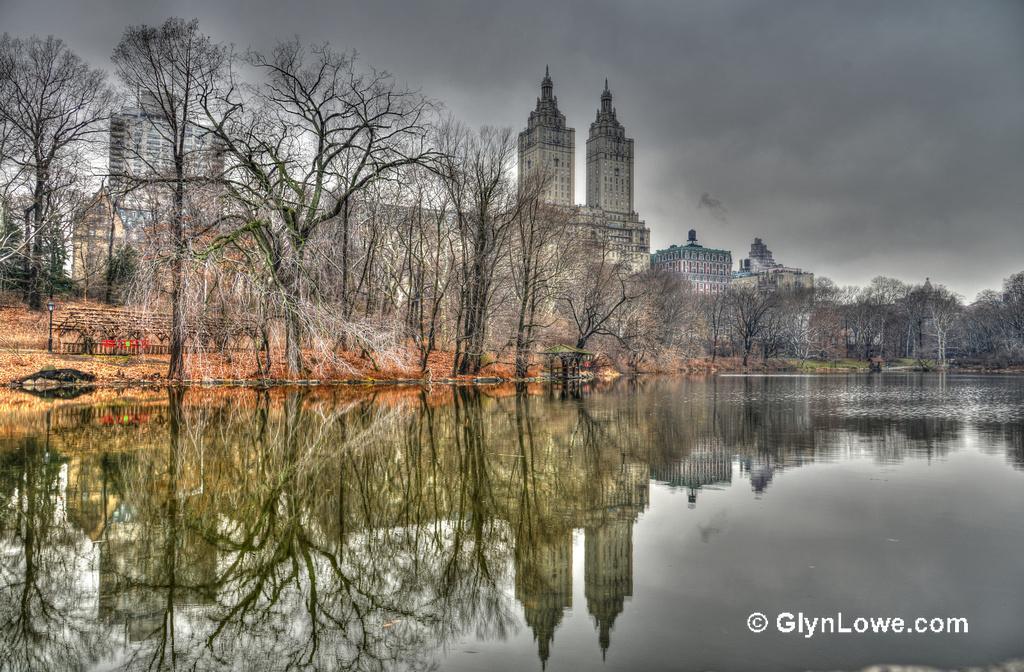Please provide a concise description of this image. In this picture we can see water, trees, buildings, light pole and some objects and in the background we can see the sky with clouds. 